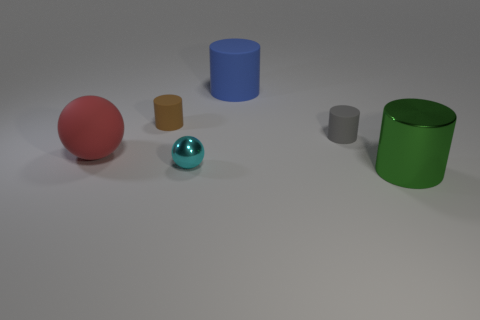Subtract all cyan cylinders. Subtract all cyan blocks. How many cylinders are left? 4 Add 3 green cylinders. How many objects exist? 9 Subtract all cylinders. How many objects are left? 2 Subtract 0 green cubes. How many objects are left? 6 Subtract all small shiny things. Subtract all matte cylinders. How many objects are left? 2 Add 1 tiny gray cylinders. How many tiny gray cylinders are left? 2 Add 3 small matte things. How many small matte things exist? 5 